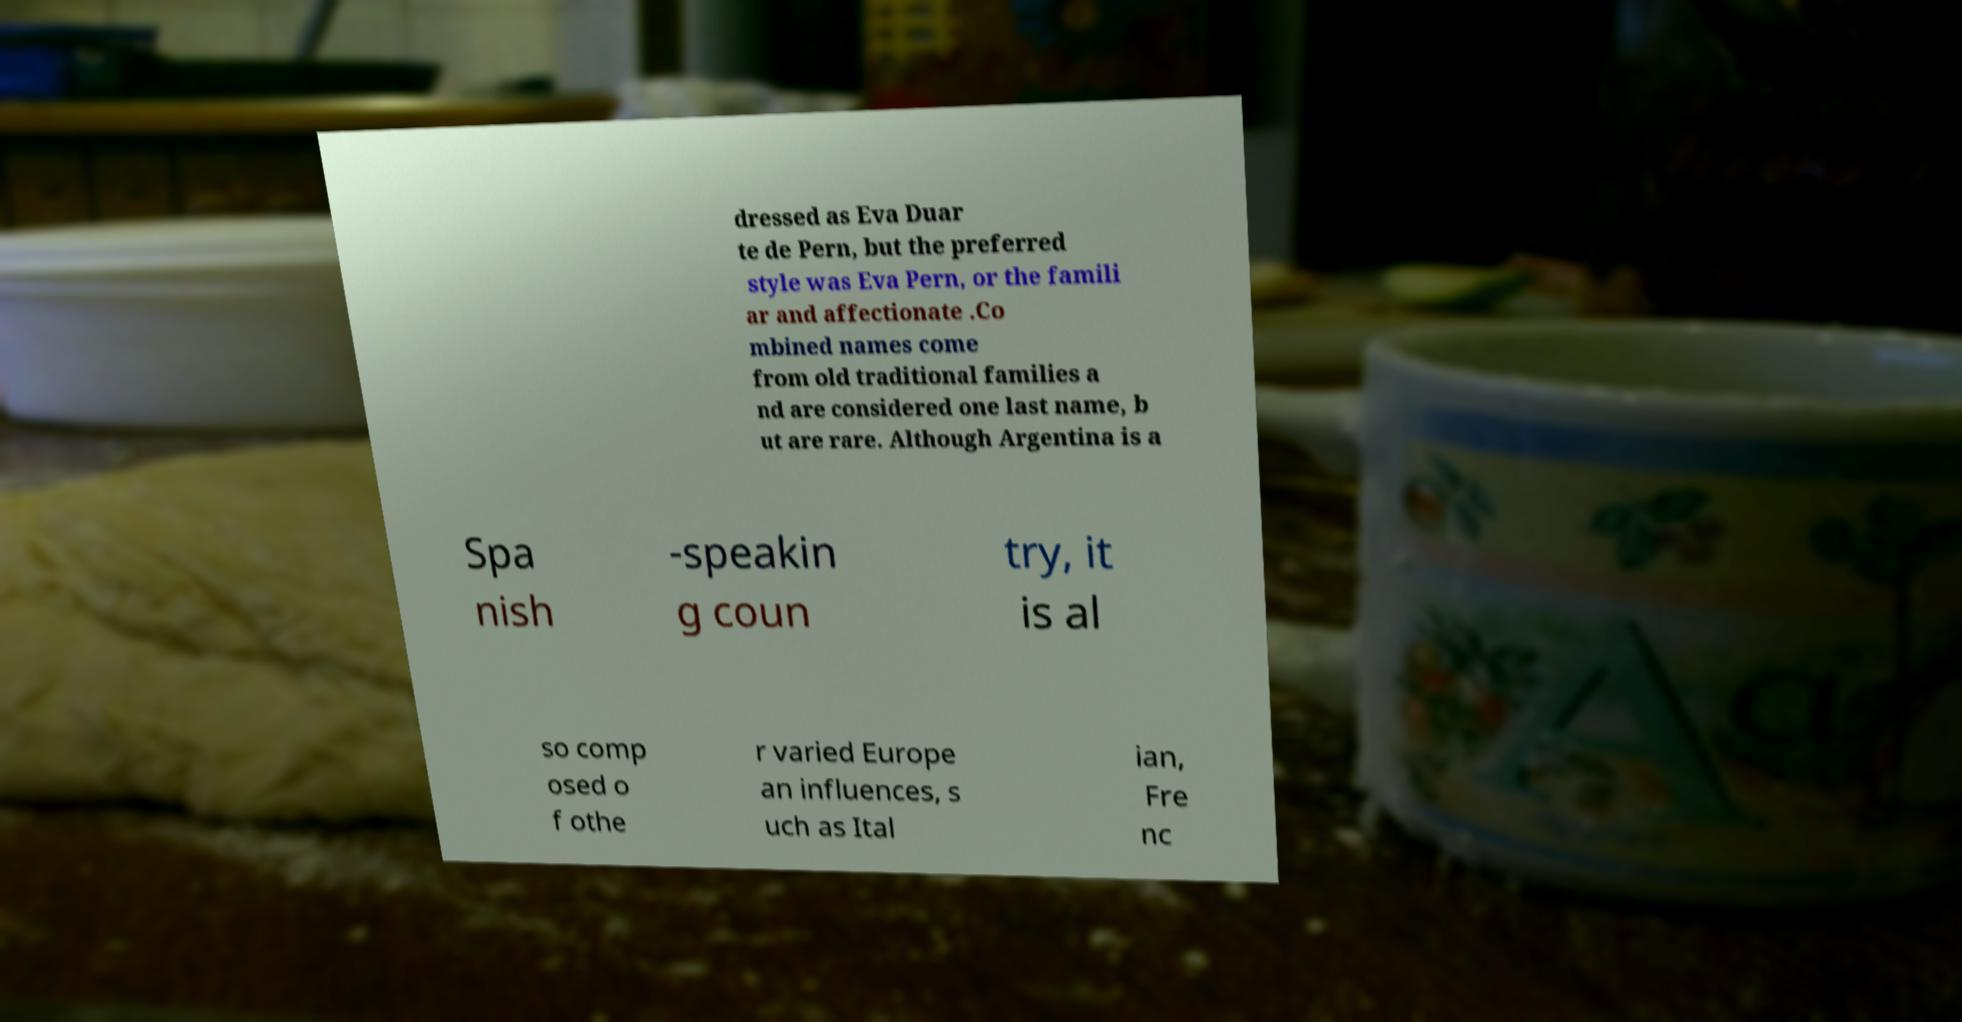What messages or text are displayed in this image? I need them in a readable, typed format. dressed as Eva Duar te de Pern, but the preferred style was Eva Pern, or the famili ar and affectionate .Co mbined names come from old traditional families a nd are considered one last name, b ut are rare. Although Argentina is a Spa nish -speakin g coun try, it is al so comp osed o f othe r varied Europe an influences, s uch as Ital ian, Fre nc 